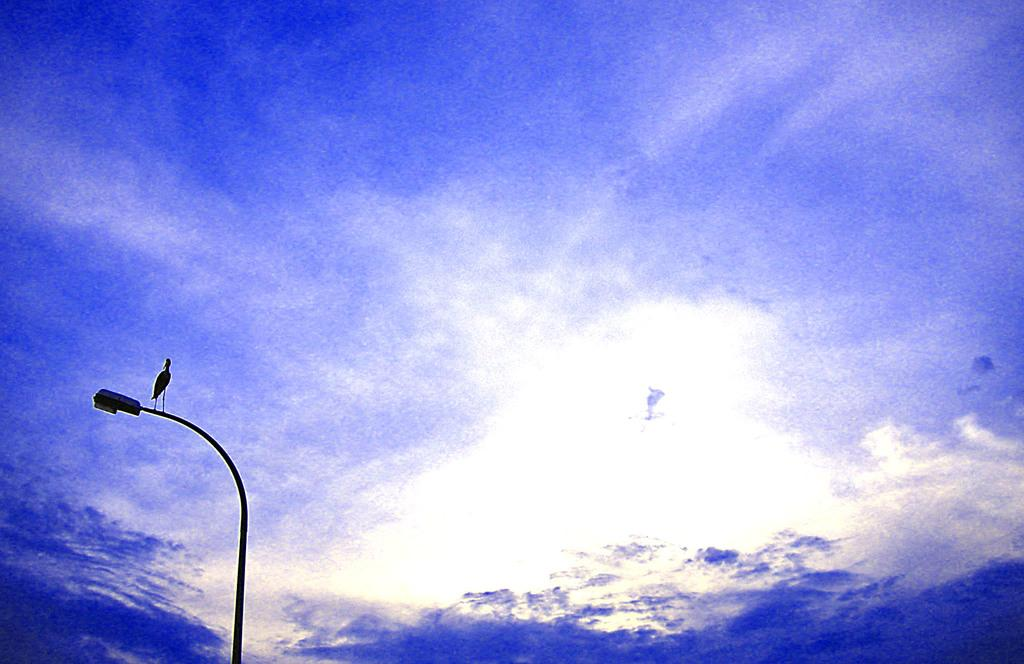What is located on the street light in the image? There is a bird on a street light in the image. What can be seen in the background of the image? The sky is visible in the background of the image. What type of cannon is present on the side of the bird in the image? There is no cannon present in the image, and the bird is not associated with any cannon. 